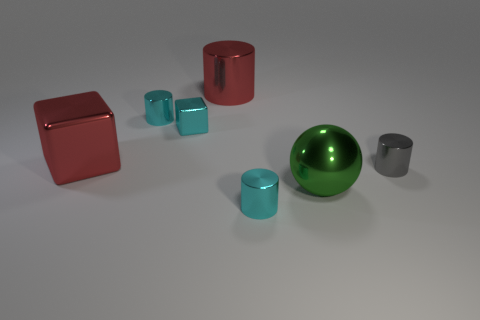Add 1 metallic balls. How many objects exist? 8 Subtract all spheres. How many objects are left? 6 Subtract all blocks. Subtract all tiny metal cylinders. How many objects are left? 2 Add 3 green shiny spheres. How many green shiny spheres are left? 4 Add 2 large brown cylinders. How many large brown cylinders exist? 2 Subtract 0 gray balls. How many objects are left? 7 